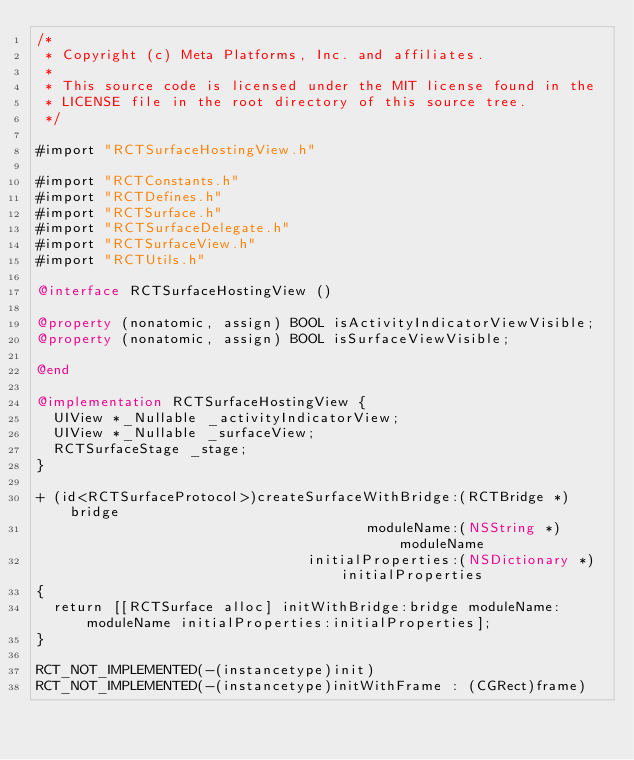<code> <loc_0><loc_0><loc_500><loc_500><_ObjectiveC_>/*
 * Copyright (c) Meta Platforms, Inc. and affiliates.
 *
 * This source code is licensed under the MIT license found in the
 * LICENSE file in the root directory of this source tree.
 */

#import "RCTSurfaceHostingView.h"

#import "RCTConstants.h"
#import "RCTDefines.h"
#import "RCTSurface.h"
#import "RCTSurfaceDelegate.h"
#import "RCTSurfaceView.h"
#import "RCTUtils.h"

@interface RCTSurfaceHostingView ()

@property (nonatomic, assign) BOOL isActivityIndicatorViewVisible;
@property (nonatomic, assign) BOOL isSurfaceViewVisible;

@end

@implementation RCTSurfaceHostingView {
  UIView *_Nullable _activityIndicatorView;
  UIView *_Nullable _surfaceView;
  RCTSurfaceStage _stage;
}

+ (id<RCTSurfaceProtocol>)createSurfaceWithBridge:(RCTBridge *)bridge
                                       moduleName:(NSString *)moduleName
                                initialProperties:(NSDictionary *)initialProperties
{
  return [[RCTSurface alloc] initWithBridge:bridge moduleName:moduleName initialProperties:initialProperties];
}

RCT_NOT_IMPLEMENTED(-(instancetype)init)
RCT_NOT_IMPLEMENTED(-(instancetype)initWithFrame : (CGRect)frame)</code> 